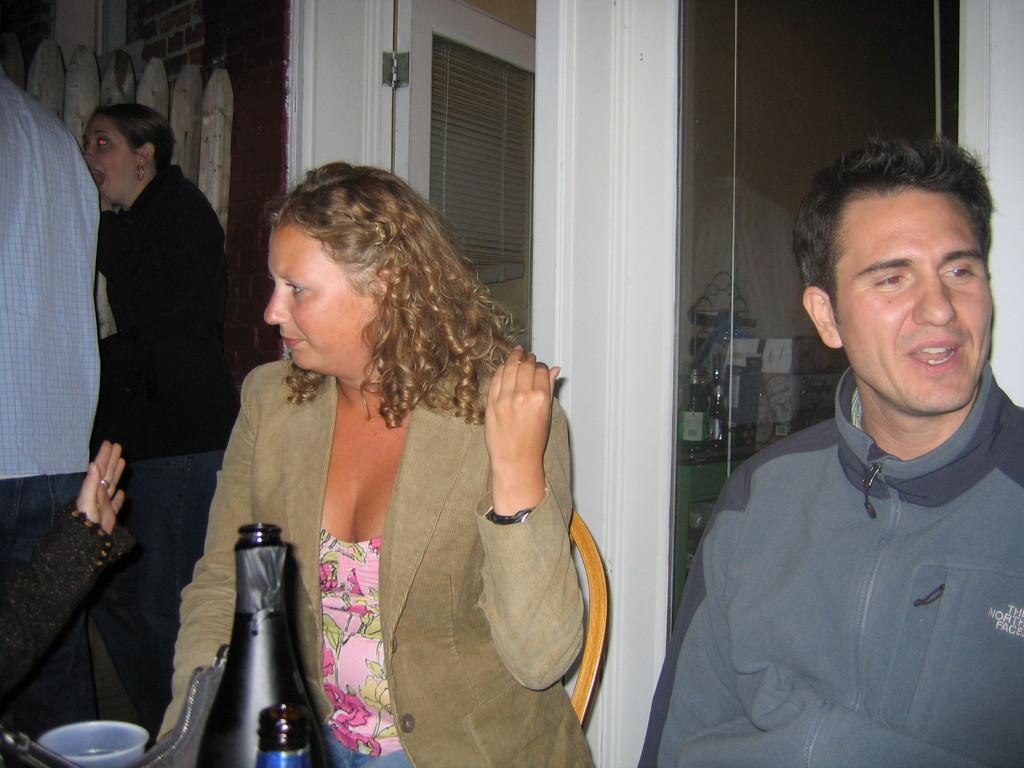What is one of the main objects in the image? There is a door in the image. What are the two people in the image doing? Two people are sitting on chairs in the image. What type of object can be seen in black color? There is a black color bottle in the image. What might be used for drinking in the image? There is a glass in the image. Can you hear the bells ringing in the image? There are no bells present in the image, so it is not possible to hear them ringing. 